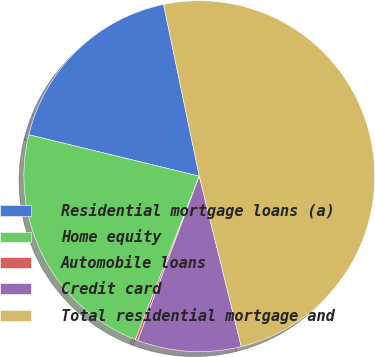Convert chart to OTSL. <chart><loc_0><loc_0><loc_500><loc_500><pie_chart><fcel>Residential mortgage loans (a)<fcel>Home equity<fcel>Automobile loans<fcel>Credit card<fcel>Total residential mortgage and<nl><fcel>17.94%<fcel>22.86%<fcel>0.23%<fcel>9.55%<fcel>49.41%<nl></chart> 